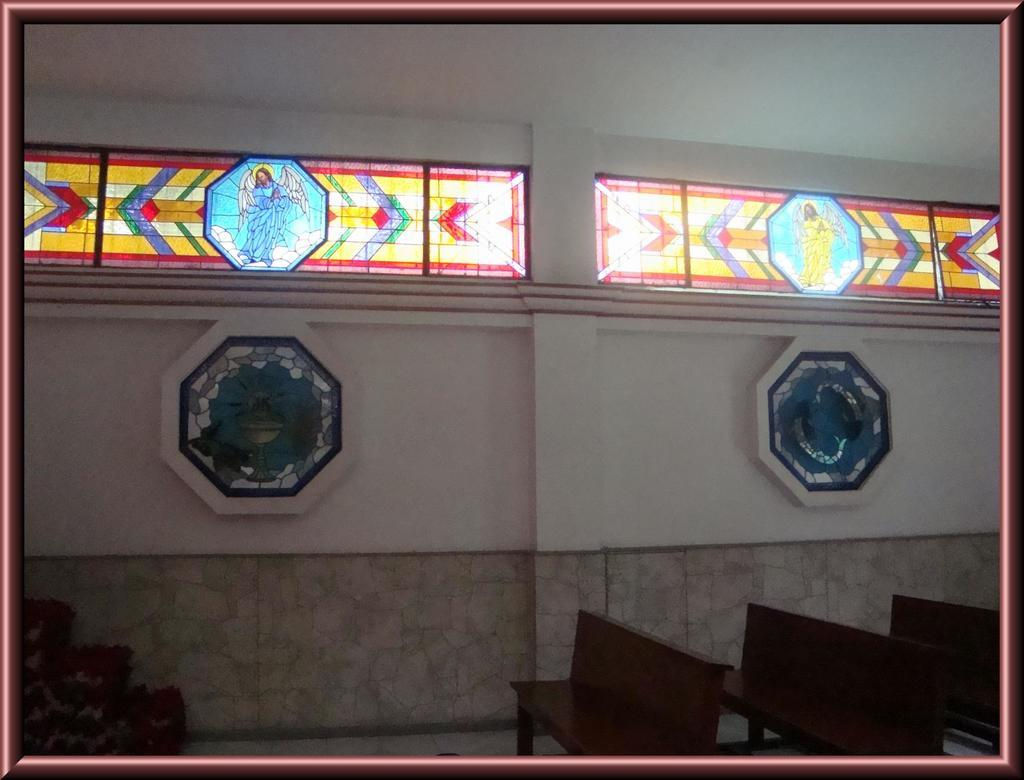How many benches are visible in the front of the image? There are three benches in the front of the image. What can be seen in the background of the image? There is a wall and glass windows in the background of the image. What is depicted on the glass windows? There are depiction pictures on the glass windows. What is the tendency of the bubbles in the image? There are no bubbles present in the image. 